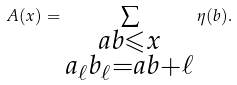<formula> <loc_0><loc_0><loc_500><loc_500>A ( x ) = \sum _ { \substack { a b \leqslant x \\ a _ { \ell } b _ { \ell } = a b + \ell } } \eta ( b ) .</formula> 